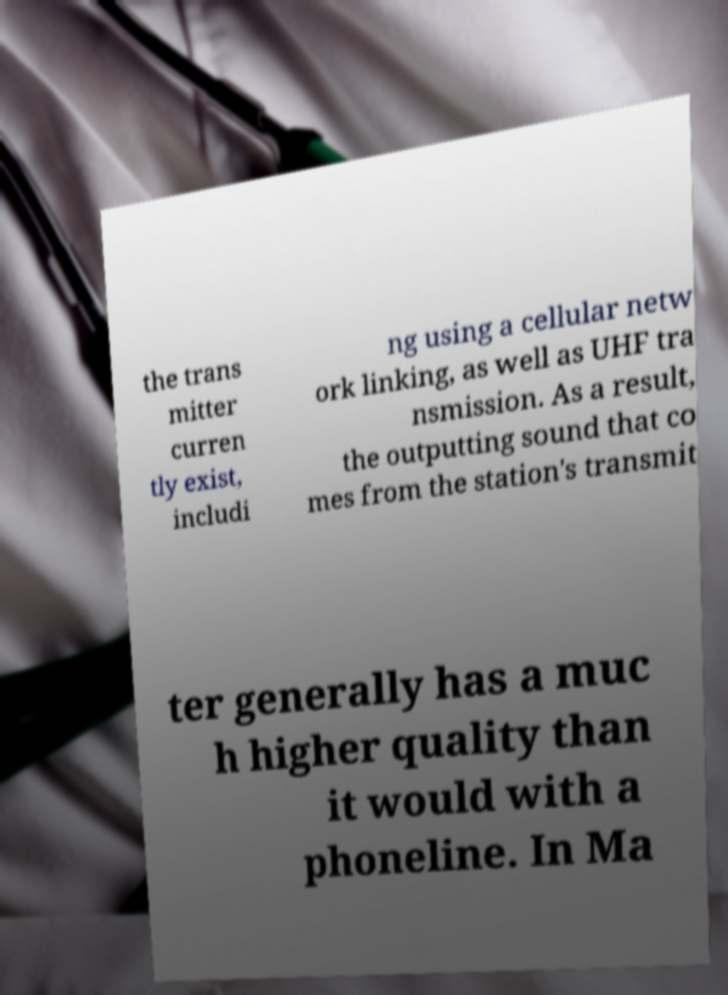I need the written content from this picture converted into text. Can you do that? the trans mitter curren tly exist, includi ng using a cellular netw ork linking, as well as UHF tra nsmission. As a result, the outputting sound that co mes from the station's transmit ter generally has a muc h higher quality than it would with a phoneline. In Ma 